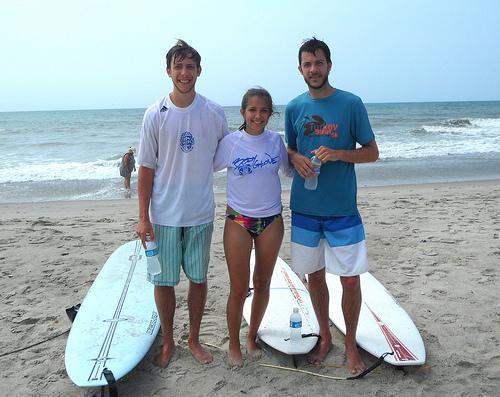How many people are shown?
Give a very brief answer. 3. How many water bottles are being held?
Give a very brief answer. 2. 